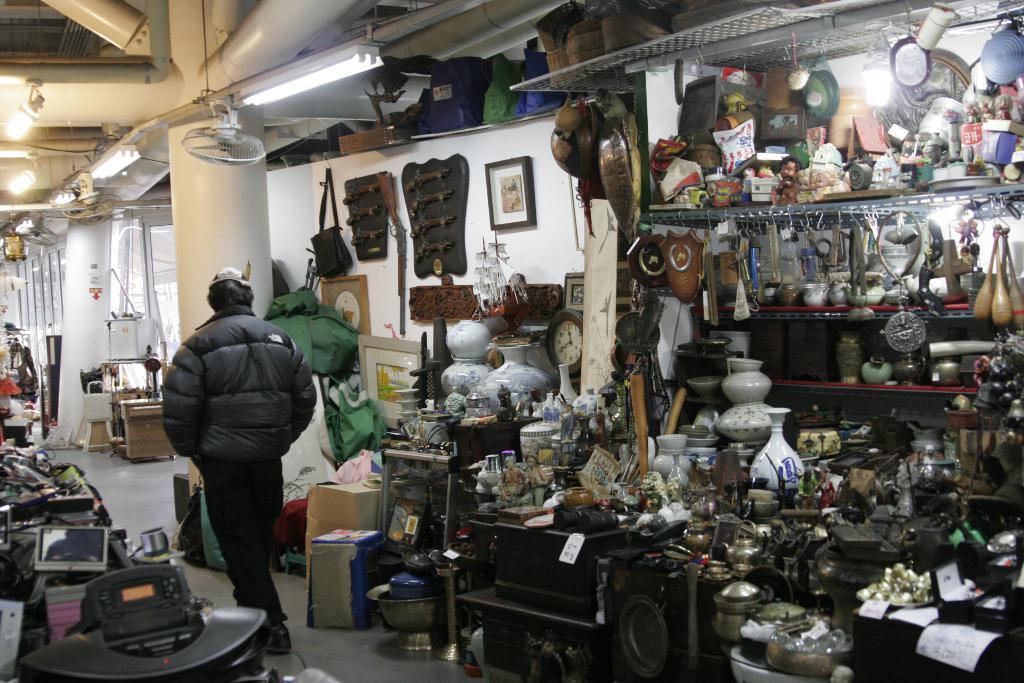Can you describe this image briefly? In this picture I can see few posts and I can see photo frame on the wall and I can see few bags and few items on the floor and I can see few lights on the ceiling. 